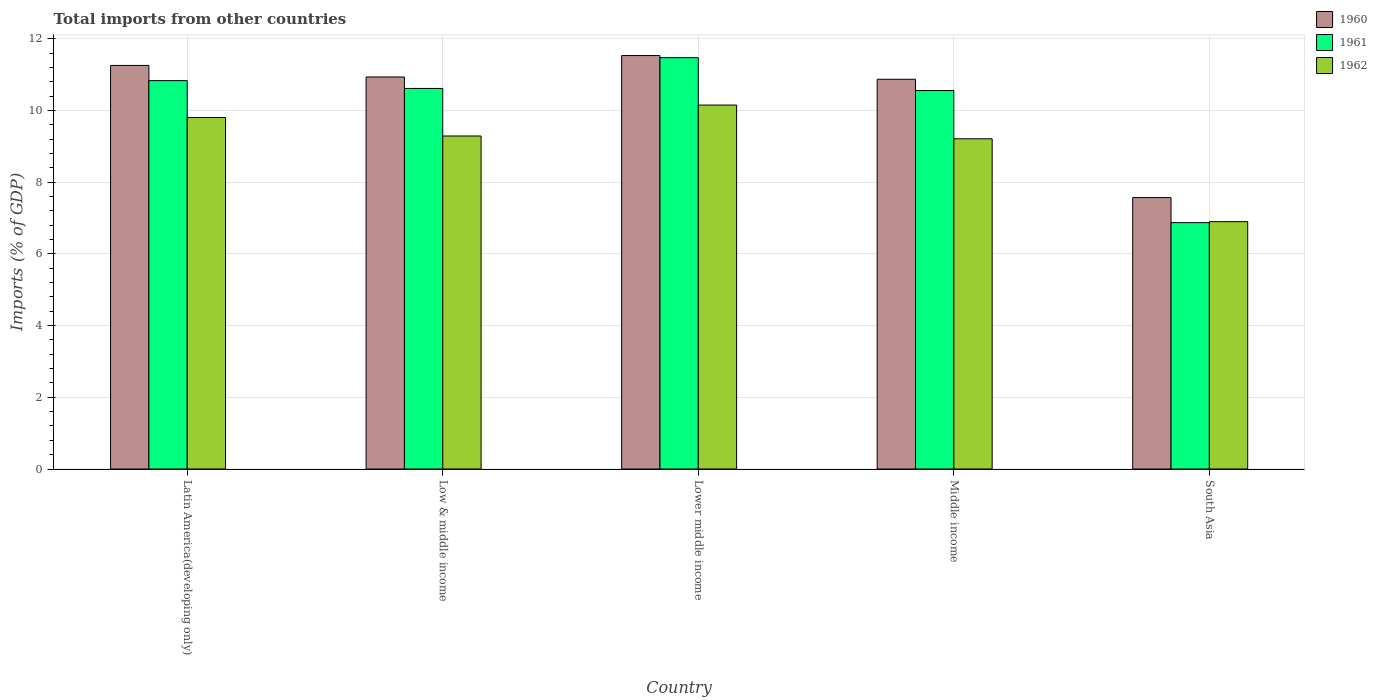How many different coloured bars are there?
Offer a very short reply. 3. How many groups of bars are there?
Offer a very short reply. 5. How many bars are there on the 2nd tick from the left?
Give a very brief answer. 3. What is the label of the 1st group of bars from the left?
Offer a very short reply. Latin America(developing only). What is the total imports in 1960 in South Asia?
Ensure brevity in your answer.  7.57. Across all countries, what is the maximum total imports in 1962?
Your answer should be very brief. 10.15. Across all countries, what is the minimum total imports in 1961?
Your answer should be very brief. 6.87. In which country was the total imports in 1961 maximum?
Offer a very short reply. Lower middle income. What is the total total imports in 1961 in the graph?
Provide a short and direct response. 50.34. What is the difference between the total imports in 1962 in Latin America(developing only) and that in South Asia?
Your answer should be compact. 2.9. What is the difference between the total imports in 1960 in Low & middle income and the total imports in 1962 in Middle income?
Offer a terse response. 1.72. What is the average total imports in 1960 per country?
Ensure brevity in your answer.  10.43. What is the difference between the total imports of/in 1960 and total imports of/in 1961 in South Asia?
Offer a terse response. 0.7. What is the ratio of the total imports in 1962 in Latin America(developing only) to that in Lower middle income?
Provide a succinct answer. 0.97. Is the difference between the total imports in 1960 in Low & middle income and Lower middle income greater than the difference between the total imports in 1961 in Low & middle income and Lower middle income?
Offer a terse response. Yes. What is the difference between the highest and the second highest total imports in 1962?
Give a very brief answer. -0.35. What is the difference between the highest and the lowest total imports in 1962?
Keep it short and to the point. 3.25. Is the sum of the total imports in 1961 in Low & middle income and Lower middle income greater than the maximum total imports in 1960 across all countries?
Make the answer very short. Yes. What does the 1st bar from the left in Middle income represents?
Offer a terse response. 1960. What does the 3rd bar from the right in Lower middle income represents?
Provide a short and direct response. 1960. Is it the case that in every country, the sum of the total imports in 1962 and total imports in 1960 is greater than the total imports in 1961?
Make the answer very short. Yes. How many bars are there?
Ensure brevity in your answer.  15. Does the graph contain any zero values?
Keep it short and to the point. No. Does the graph contain grids?
Your answer should be compact. Yes. Where does the legend appear in the graph?
Provide a succinct answer. Top right. How many legend labels are there?
Provide a short and direct response. 3. What is the title of the graph?
Provide a succinct answer. Total imports from other countries. What is the label or title of the X-axis?
Your response must be concise. Country. What is the label or title of the Y-axis?
Your answer should be very brief. Imports (% of GDP). What is the Imports (% of GDP) in 1960 in Latin America(developing only)?
Your answer should be very brief. 11.25. What is the Imports (% of GDP) of 1961 in Latin America(developing only)?
Your answer should be very brief. 10.83. What is the Imports (% of GDP) in 1962 in Latin America(developing only)?
Give a very brief answer. 9.8. What is the Imports (% of GDP) of 1960 in Low & middle income?
Offer a terse response. 10.93. What is the Imports (% of GDP) in 1961 in Low & middle income?
Offer a terse response. 10.61. What is the Imports (% of GDP) in 1962 in Low & middle income?
Your answer should be very brief. 9.29. What is the Imports (% of GDP) in 1960 in Lower middle income?
Your answer should be very brief. 11.53. What is the Imports (% of GDP) of 1961 in Lower middle income?
Ensure brevity in your answer.  11.47. What is the Imports (% of GDP) of 1962 in Lower middle income?
Keep it short and to the point. 10.15. What is the Imports (% of GDP) of 1960 in Middle income?
Ensure brevity in your answer.  10.87. What is the Imports (% of GDP) of 1961 in Middle income?
Make the answer very short. 10.55. What is the Imports (% of GDP) of 1962 in Middle income?
Give a very brief answer. 9.21. What is the Imports (% of GDP) of 1960 in South Asia?
Make the answer very short. 7.57. What is the Imports (% of GDP) of 1961 in South Asia?
Your answer should be very brief. 6.87. What is the Imports (% of GDP) in 1962 in South Asia?
Your answer should be very brief. 6.9. Across all countries, what is the maximum Imports (% of GDP) in 1960?
Offer a terse response. 11.53. Across all countries, what is the maximum Imports (% of GDP) in 1961?
Give a very brief answer. 11.47. Across all countries, what is the maximum Imports (% of GDP) in 1962?
Ensure brevity in your answer.  10.15. Across all countries, what is the minimum Imports (% of GDP) in 1960?
Provide a short and direct response. 7.57. Across all countries, what is the minimum Imports (% of GDP) of 1961?
Your answer should be very brief. 6.87. Across all countries, what is the minimum Imports (% of GDP) in 1962?
Your answer should be compact. 6.9. What is the total Imports (% of GDP) in 1960 in the graph?
Give a very brief answer. 52.15. What is the total Imports (% of GDP) of 1961 in the graph?
Your answer should be very brief. 50.34. What is the total Imports (% of GDP) of 1962 in the graph?
Offer a very short reply. 45.34. What is the difference between the Imports (% of GDP) of 1960 in Latin America(developing only) and that in Low & middle income?
Provide a succinct answer. 0.32. What is the difference between the Imports (% of GDP) in 1961 in Latin America(developing only) and that in Low & middle income?
Give a very brief answer. 0.22. What is the difference between the Imports (% of GDP) in 1962 in Latin America(developing only) and that in Low & middle income?
Make the answer very short. 0.52. What is the difference between the Imports (% of GDP) of 1960 in Latin America(developing only) and that in Lower middle income?
Your answer should be compact. -0.28. What is the difference between the Imports (% of GDP) of 1961 in Latin America(developing only) and that in Lower middle income?
Your response must be concise. -0.64. What is the difference between the Imports (% of GDP) in 1962 in Latin America(developing only) and that in Lower middle income?
Offer a terse response. -0.35. What is the difference between the Imports (% of GDP) in 1960 in Latin America(developing only) and that in Middle income?
Make the answer very short. 0.39. What is the difference between the Imports (% of GDP) in 1961 in Latin America(developing only) and that in Middle income?
Your answer should be compact. 0.28. What is the difference between the Imports (% of GDP) of 1962 in Latin America(developing only) and that in Middle income?
Offer a very short reply. 0.59. What is the difference between the Imports (% of GDP) in 1960 in Latin America(developing only) and that in South Asia?
Offer a very short reply. 3.68. What is the difference between the Imports (% of GDP) in 1961 in Latin America(developing only) and that in South Asia?
Your answer should be compact. 3.96. What is the difference between the Imports (% of GDP) of 1962 in Latin America(developing only) and that in South Asia?
Keep it short and to the point. 2.9. What is the difference between the Imports (% of GDP) of 1960 in Low & middle income and that in Lower middle income?
Provide a succinct answer. -0.6. What is the difference between the Imports (% of GDP) in 1961 in Low & middle income and that in Lower middle income?
Make the answer very short. -0.86. What is the difference between the Imports (% of GDP) of 1962 in Low & middle income and that in Lower middle income?
Provide a short and direct response. -0.86. What is the difference between the Imports (% of GDP) of 1960 in Low & middle income and that in Middle income?
Offer a very short reply. 0.06. What is the difference between the Imports (% of GDP) in 1961 in Low & middle income and that in Middle income?
Offer a terse response. 0.06. What is the difference between the Imports (% of GDP) in 1962 in Low & middle income and that in Middle income?
Your answer should be compact. 0.08. What is the difference between the Imports (% of GDP) in 1960 in Low & middle income and that in South Asia?
Provide a short and direct response. 3.36. What is the difference between the Imports (% of GDP) of 1961 in Low & middle income and that in South Asia?
Your answer should be very brief. 3.74. What is the difference between the Imports (% of GDP) in 1962 in Low & middle income and that in South Asia?
Offer a terse response. 2.39. What is the difference between the Imports (% of GDP) of 1960 in Lower middle income and that in Middle income?
Offer a terse response. 0.66. What is the difference between the Imports (% of GDP) of 1962 in Lower middle income and that in Middle income?
Provide a short and direct response. 0.94. What is the difference between the Imports (% of GDP) in 1960 in Lower middle income and that in South Asia?
Provide a succinct answer. 3.96. What is the difference between the Imports (% of GDP) in 1961 in Lower middle income and that in South Asia?
Keep it short and to the point. 4.6. What is the difference between the Imports (% of GDP) in 1962 in Lower middle income and that in South Asia?
Ensure brevity in your answer.  3.25. What is the difference between the Imports (% of GDP) in 1960 in Middle income and that in South Asia?
Provide a short and direct response. 3.3. What is the difference between the Imports (% of GDP) in 1961 in Middle income and that in South Asia?
Keep it short and to the point. 3.68. What is the difference between the Imports (% of GDP) in 1962 in Middle income and that in South Asia?
Your answer should be compact. 2.31. What is the difference between the Imports (% of GDP) of 1960 in Latin America(developing only) and the Imports (% of GDP) of 1961 in Low & middle income?
Offer a very short reply. 0.64. What is the difference between the Imports (% of GDP) of 1960 in Latin America(developing only) and the Imports (% of GDP) of 1962 in Low & middle income?
Provide a short and direct response. 1.97. What is the difference between the Imports (% of GDP) in 1961 in Latin America(developing only) and the Imports (% of GDP) in 1962 in Low & middle income?
Offer a very short reply. 1.54. What is the difference between the Imports (% of GDP) in 1960 in Latin America(developing only) and the Imports (% of GDP) in 1961 in Lower middle income?
Offer a very short reply. -0.22. What is the difference between the Imports (% of GDP) of 1960 in Latin America(developing only) and the Imports (% of GDP) of 1962 in Lower middle income?
Ensure brevity in your answer.  1.11. What is the difference between the Imports (% of GDP) in 1961 in Latin America(developing only) and the Imports (% of GDP) in 1962 in Lower middle income?
Provide a succinct answer. 0.68. What is the difference between the Imports (% of GDP) in 1960 in Latin America(developing only) and the Imports (% of GDP) in 1961 in Middle income?
Your answer should be compact. 0.7. What is the difference between the Imports (% of GDP) in 1960 in Latin America(developing only) and the Imports (% of GDP) in 1962 in Middle income?
Make the answer very short. 2.05. What is the difference between the Imports (% of GDP) in 1961 in Latin America(developing only) and the Imports (% of GDP) in 1962 in Middle income?
Keep it short and to the point. 1.62. What is the difference between the Imports (% of GDP) of 1960 in Latin America(developing only) and the Imports (% of GDP) of 1961 in South Asia?
Make the answer very short. 4.38. What is the difference between the Imports (% of GDP) of 1960 in Latin America(developing only) and the Imports (% of GDP) of 1962 in South Asia?
Make the answer very short. 4.36. What is the difference between the Imports (% of GDP) of 1961 in Latin America(developing only) and the Imports (% of GDP) of 1962 in South Asia?
Provide a succinct answer. 3.93. What is the difference between the Imports (% of GDP) in 1960 in Low & middle income and the Imports (% of GDP) in 1961 in Lower middle income?
Provide a succinct answer. -0.54. What is the difference between the Imports (% of GDP) of 1960 in Low & middle income and the Imports (% of GDP) of 1962 in Lower middle income?
Offer a very short reply. 0.78. What is the difference between the Imports (% of GDP) in 1961 in Low & middle income and the Imports (% of GDP) in 1962 in Lower middle income?
Your response must be concise. 0.46. What is the difference between the Imports (% of GDP) in 1960 in Low & middle income and the Imports (% of GDP) in 1961 in Middle income?
Give a very brief answer. 0.38. What is the difference between the Imports (% of GDP) in 1960 in Low & middle income and the Imports (% of GDP) in 1962 in Middle income?
Offer a very short reply. 1.72. What is the difference between the Imports (% of GDP) in 1961 in Low & middle income and the Imports (% of GDP) in 1962 in Middle income?
Your response must be concise. 1.4. What is the difference between the Imports (% of GDP) in 1960 in Low & middle income and the Imports (% of GDP) in 1961 in South Asia?
Offer a terse response. 4.06. What is the difference between the Imports (% of GDP) in 1960 in Low & middle income and the Imports (% of GDP) in 1962 in South Asia?
Make the answer very short. 4.03. What is the difference between the Imports (% of GDP) of 1961 in Low & middle income and the Imports (% of GDP) of 1962 in South Asia?
Offer a terse response. 3.71. What is the difference between the Imports (% of GDP) of 1960 in Lower middle income and the Imports (% of GDP) of 1961 in Middle income?
Offer a very short reply. 0.98. What is the difference between the Imports (% of GDP) of 1960 in Lower middle income and the Imports (% of GDP) of 1962 in Middle income?
Make the answer very short. 2.32. What is the difference between the Imports (% of GDP) of 1961 in Lower middle income and the Imports (% of GDP) of 1962 in Middle income?
Offer a terse response. 2.26. What is the difference between the Imports (% of GDP) in 1960 in Lower middle income and the Imports (% of GDP) in 1961 in South Asia?
Provide a succinct answer. 4.66. What is the difference between the Imports (% of GDP) of 1960 in Lower middle income and the Imports (% of GDP) of 1962 in South Asia?
Provide a succinct answer. 4.63. What is the difference between the Imports (% of GDP) in 1961 in Lower middle income and the Imports (% of GDP) in 1962 in South Asia?
Give a very brief answer. 4.57. What is the difference between the Imports (% of GDP) in 1960 in Middle income and the Imports (% of GDP) in 1961 in South Asia?
Your answer should be very brief. 4. What is the difference between the Imports (% of GDP) of 1960 in Middle income and the Imports (% of GDP) of 1962 in South Asia?
Provide a short and direct response. 3.97. What is the difference between the Imports (% of GDP) of 1961 in Middle income and the Imports (% of GDP) of 1962 in South Asia?
Offer a very short reply. 3.66. What is the average Imports (% of GDP) in 1960 per country?
Give a very brief answer. 10.43. What is the average Imports (% of GDP) in 1961 per country?
Offer a very short reply. 10.07. What is the average Imports (% of GDP) in 1962 per country?
Ensure brevity in your answer.  9.07. What is the difference between the Imports (% of GDP) in 1960 and Imports (% of GDP) in 1961 in Latin America(developing only)?
Make the answer very short. 0.42. What is the difference between the Imports (% of GDP) in 1960 and Imports (% of GDP) in 1962 in Latin America(developing only)?
Provide a succinct answer. 1.45. What is the difference between the Imports (% of GDP) of 1961 and Imports (% of GDP) of 1962 in Latin America(developing only)?
Your answer should be compact. 1.03. What is the difference between the Imports (% of GDP) of 1960 and Imports (% of GDP) of 1961 in Low & middle income?
Your response must be concise. 0.32. What is the difference between the Imports (% of GDP) in 1960 and Imports (% of GDP) in 1962 in Low & middle income?
Your response must be concise. 1.65. What is the difference between the Imports (% of GDP) in 1961 and Imports (% of GDP) in 1962 in Low & middle income?
Provide a short and direct response. 1.33. What is the difference between the Imports (% of GDP) in 1960 and Imports (% of GDP) in 1961 in Lower middle income?
Provide a short and direct response. 0.06. What is the difference between the Imports (% of GDP) of 1960 and Imports (% of GDP) of 1962 in Lower middle income?
Give a very brief answer. 1.38. What is the difference between the Imports (% of GDP) in 1961 and Imports (% of GDP) in 1962 in Lower middle income?
Your answer should be compact. 1.32. What is the difference between the Imports (% of GDP) in 1960 and Imports (% of GDP) in 1961 in Middle income?
Your answer should be compact. 0.31. What is the difference between the Imports (% of GDP) of 1960 and Imports (% of GDP) of 1962 in Middle income?
Provide a succinct answer. 1.66. What is the difference between the Imports (% of GDP) in 1961 and Imports (% of GDP) in 1962 in Middle income?
Your response must be concise. 1.35. What is the difference between the Imports (% of GDP) of 1960 and Imports (% of GDP) of 1961 in South Asia?
Your response must be concise. 0.7. What is the difference between the Imports (% of GDP) of 1960 and Imports (% of GDP) of 1962 in South Asia?
Your response must be concise. 0.67. What is the difference between the Imports (% of GDP) of 1961 and Imports (% of GDP) of 1962 in South Asia?
Give a very brief answer. -0.03. What is the ratio of the Imports (% of GDP) of 1960 in Latin America(developing only) to that in Low & middle income?
Ensure brevity in your answer.  1.03. What is the ratio of the Imports (% of GDP) of 1961 in Latin America(developing only) to that in Low & middle income?
Your response must be concise. 1.02. What is the ratio of the Imports (% of GDP) of 1962 in Latin America(developing only) to that in Low & middle income?
Offer a very short reply. 1.06. What is the ratio of the Imports (% of GDP) in 1960 in Latin America(developing only) to that in Lower middle income?
Your answer should be compact. 0.98. What is the ratio of the Imports (% of GDP) in 1961 in Latin America(developing only) to that in Lower middle income?
Ensure brevity in your answer.  0.94. What is the ratio of the Imports (% of GDP) of 1962 in Latin America(developing only) to that in Lower middle income?
Offer a very short reply. 0.97. What is the ratio of the Imports (% of GDP) in 1960 in Latin America(developing only) to that in Middle income?
Give a very brief answer. 1.04. What is the ratio of the Imports (% of GDP) in 1961 in Latin America(developing only) to that in Middle income?
Offer a terse response. 1.03. What is the ratio of the Imports (% of GDP) in 1962 in Latin America(developing only) to that in Middle income?
Make the answer very short. 1.06. What is the ratio of the Imports (% of GDP) in 1960 in Latin America(developing only) to that in South Asia?
Make the answer very short. 1.49. What is the ratio of the Imports (% of GDP) of 1961 in Latin America(developing only) to that in South Asia?
Offer a terse response. 1.58. What is the ratio of the Imports (% of GDP) of 1962 in Latin America(developing only) to that in South Asia?
Keep it short and to the point. 1.42. What is the ratio of the Imports (% of GDP) in 1960 in Low & middle income to that in Lower middle income?
Offer a terse response. 0.95. What is the ratio of the Imports (% of GDP) in 1961 in Low & middle income to that in Lower middle income?
Offer a very short reply. 0.93. What is the ratio of the Imports (% of GDP) in 1962 in Low & middle income to that in Lower middle income?
Offer a very short reply. 0.92. What is the ratio of the Imports (% of GDP) of 1960 in Low & middle income to that in Middle income?
Your answer should be compact. 1.01. What is the ratio of the Imports (% of GDP) of 1961 in Low & middle income to that in Middle income?
Your response must be concise. 1.01. What is the ratio of the Imports (% of GDP) in 1962 in Low & middle income to that in Middle income?
Offer a very short reply. 1.01. What is the ratio of the Imports (% of GDP) of 1960 in Low & middle income to that in South Asia?
Your response must be concise. 1.44. What is the ratio of the Imports (% of GDP) in 1961 in Low & middle income to that in South Asia?
Your answer should be very brief. 1.54. What is the ratio of the Imports (% of GDP) in 1962 in Low & middle income to that in South Asia?
Your answer should be very brief. 1.35. What is the ratio of the Imports (% of GDP) in 1960 in Lower middle income to that in Middle income?
Provide a succinct answer. 1.06. What is the ratio of the Imports (% of GDP) of 1961 in Lower middle income to that in Middle income?
Make the answer very short. 1.09. What is the ratio of the Imports (% of GDP) of 1962 in Lower middle income to that in Middle income?
Provide a short and direct response. 1.1. What is the ratio of the Imports (% of GDP) in 1960 in Lower middle income to that in South Asia?
Keep it short and to the point. 1.52. What is the ratio of the Imports (% of GDP) of 1961 in Lower middle income to that in South Asia?
Give a very brief answer. 1.67. What is the ratio of the Imports (% of GDP) in 1962 in Lower middle income to that in South Asia?
Offer a very short reply. 1.47. What is the ratio of the Imports (% of GDP) of 1960 in Middle income to that in South Asia?
Make the answer very short. 1.44. What is the ratio of the Imports (% of GDP) of 1961 in Middle income to that in South Asia?
Offer a terse response. 1.54. What is the ratio of the Imports (% of GDP) in 1962 in Middle income to that in South Asia?
Provide a succinct answer. 1.33. What is the difference between the highest and the second highest Imports (% of GDP) of 1960?
Your answer should be very brief. 0.28. What is the difference between the highest and the second highest Imports (% of GDP) in 1961?
Your answer should be compact. 0.64. What is the difference between the highest and the second highest Imports (% of GDP) in 1962?
Provide a succinct answer. 0.35. What is the difference between the highest and the lowest Imports (% of GDP) of 1960?
Your answer should be compact. 3.96. What is the difference between the highest and the lowest Imports (% of GDP) in 1961?
Provide a short and direct response. 4.6. What is the difference between the highest and the lowest Imports (% of GDP) of 1962?
Make the answer very short. 3.25. 